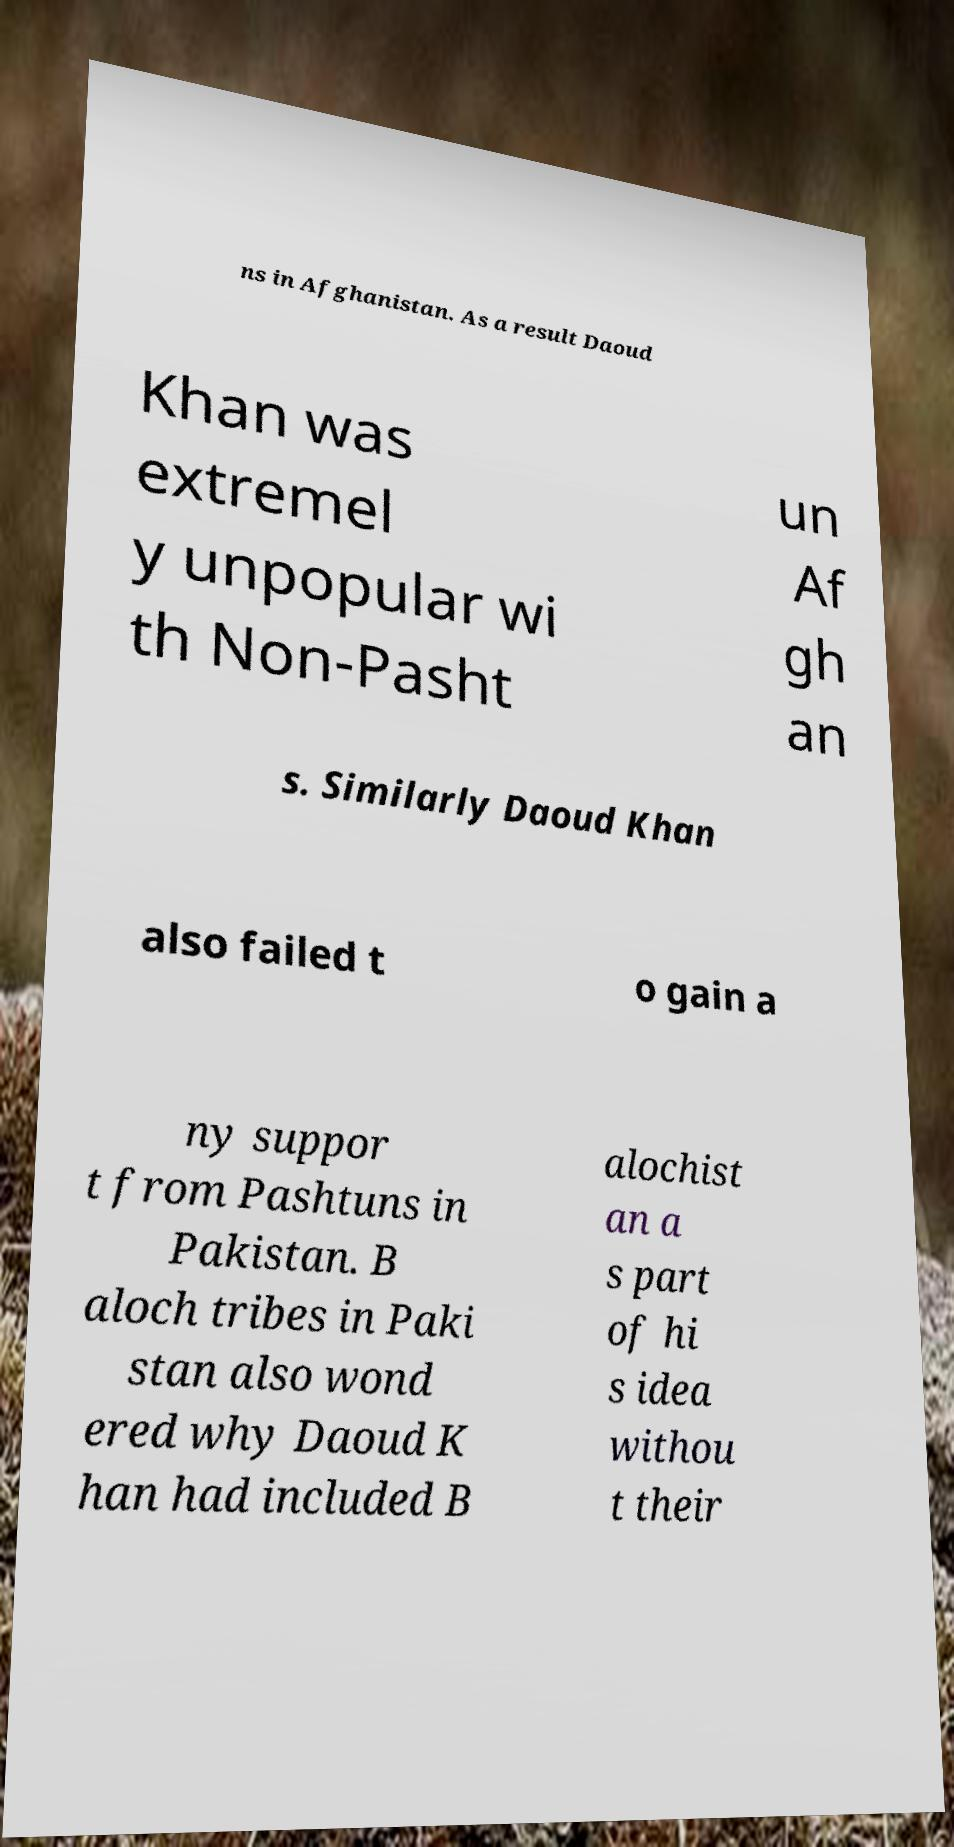I need the written content from this picture converted into text. Can you do that? ns in Afghanistan. As a result Daoud Khan was extremel y unpopular wi th Non-Pasht un Af gh an s. Similarly Daoud Khan also failed t o gain a ny suppor t from Pashtuns in Pakistan. B aloch tribes in Paki stan also wond ered why Daoud K han had included B alochist an a s part of hi s idea withou t their 